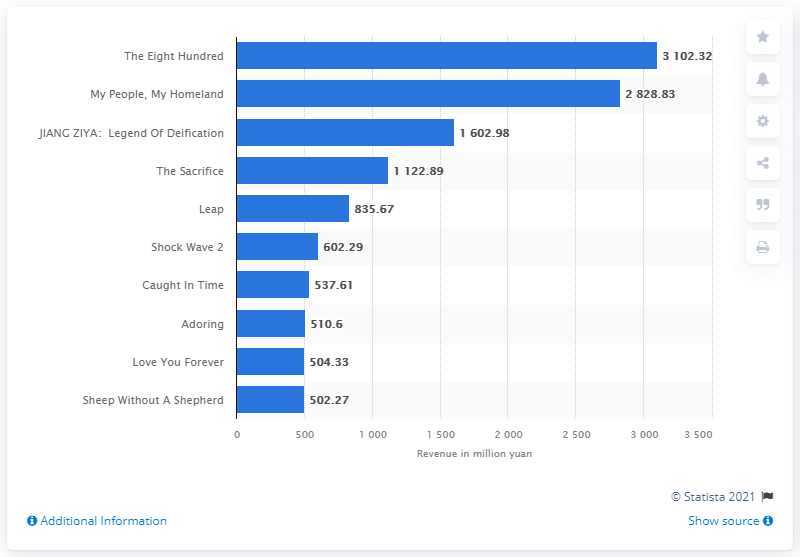Outline some significant characteristics in this image. The Eight Hundred was the highest grossing movie in China in 2020. 